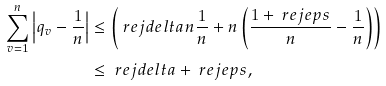<formula> <loc_0><loc_0><loc_500><loc_500>\sum _ { v = 1 } ^ { n } \left | q _ { v } - \frac { 1 } { n } \right | & \leq \left ( \ r e j d e l t a n \frac { 1 } { n } + n \left ( \frac { 1 + \ r e j e p s } { n } - \frac { 1 } { n } \right ) \right ) \\ & \leq \ r e j d e l t a + \ r e j e p s ,</formula> 